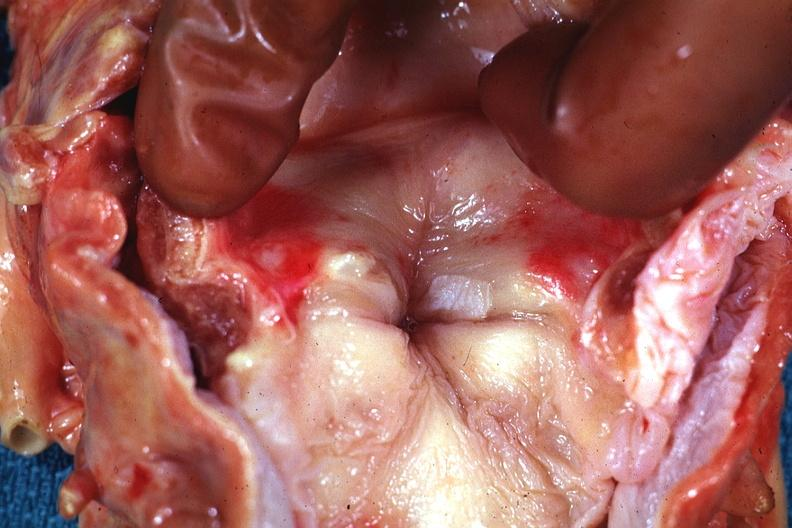s leukoplakia vocal cord present?
Answer the question using a single word or phrase. Yes 